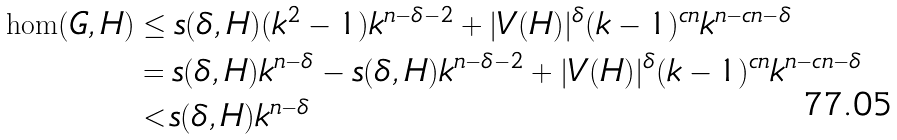<formula> <loc_0><loc_0><loc_500><loc_500>\hom ( G , H ) & \leq s ( \delta , H ) ( k ^ { 2 } - 1 ) k ^ { n - \delta - 2 } + | V ( H ) | ^ { \delta } ( k - 1 ) ^ { c n } k ^ { n - c n - \delta } \\ & = s ( \delta , H ) k ^ { n - \delta } - s ( \delta , H ) k ^ { n - \delta - 2 } + | V ( H ) | ^ { \delta } ( k - 1 ) ^ { c n } k ^ { n - c n - \delta } \\ & < s ( \delta , H ) k ^ { n - \delta }</formula> 